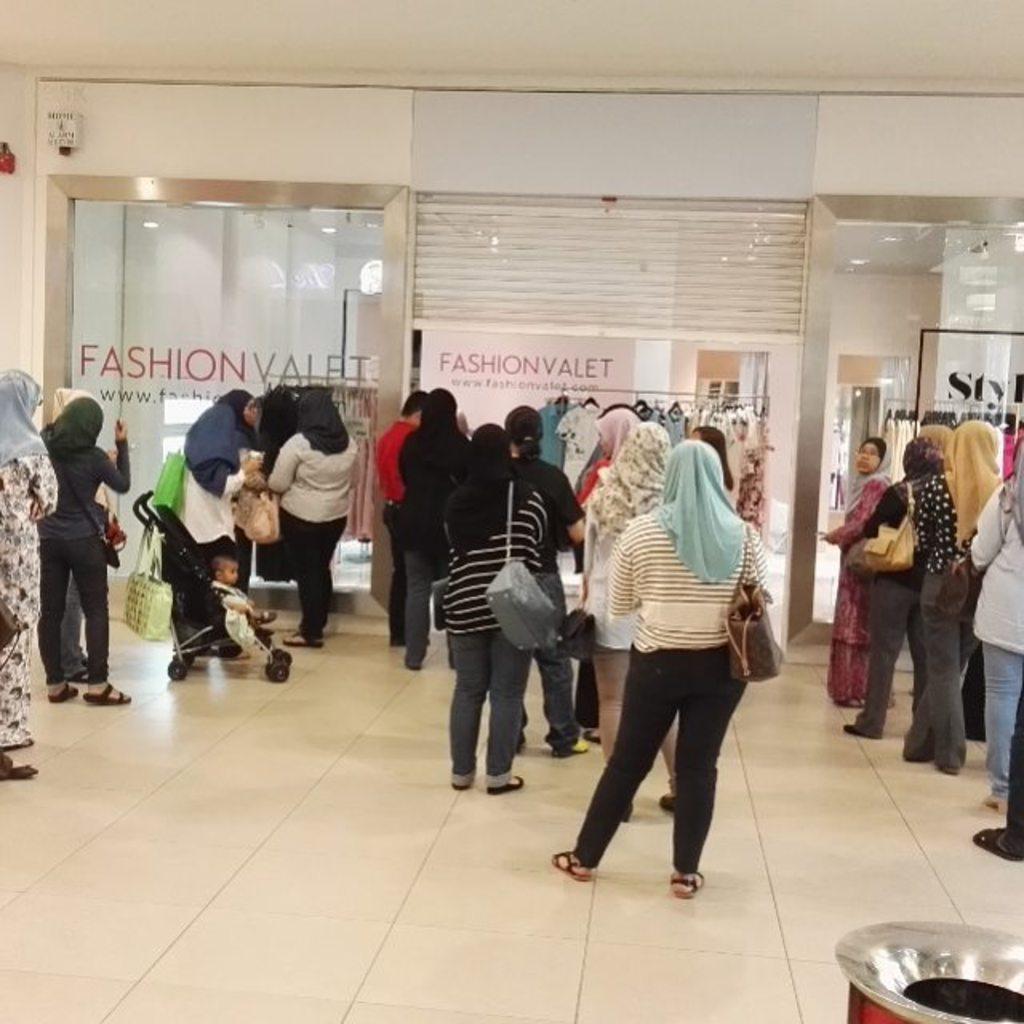How would you summarize this image in a sentence or two? In this image there are many women standing on the floor. In front of them there are dresses hanged to the hangers to a rod. There are glass walls. There is text on the glass walls. 